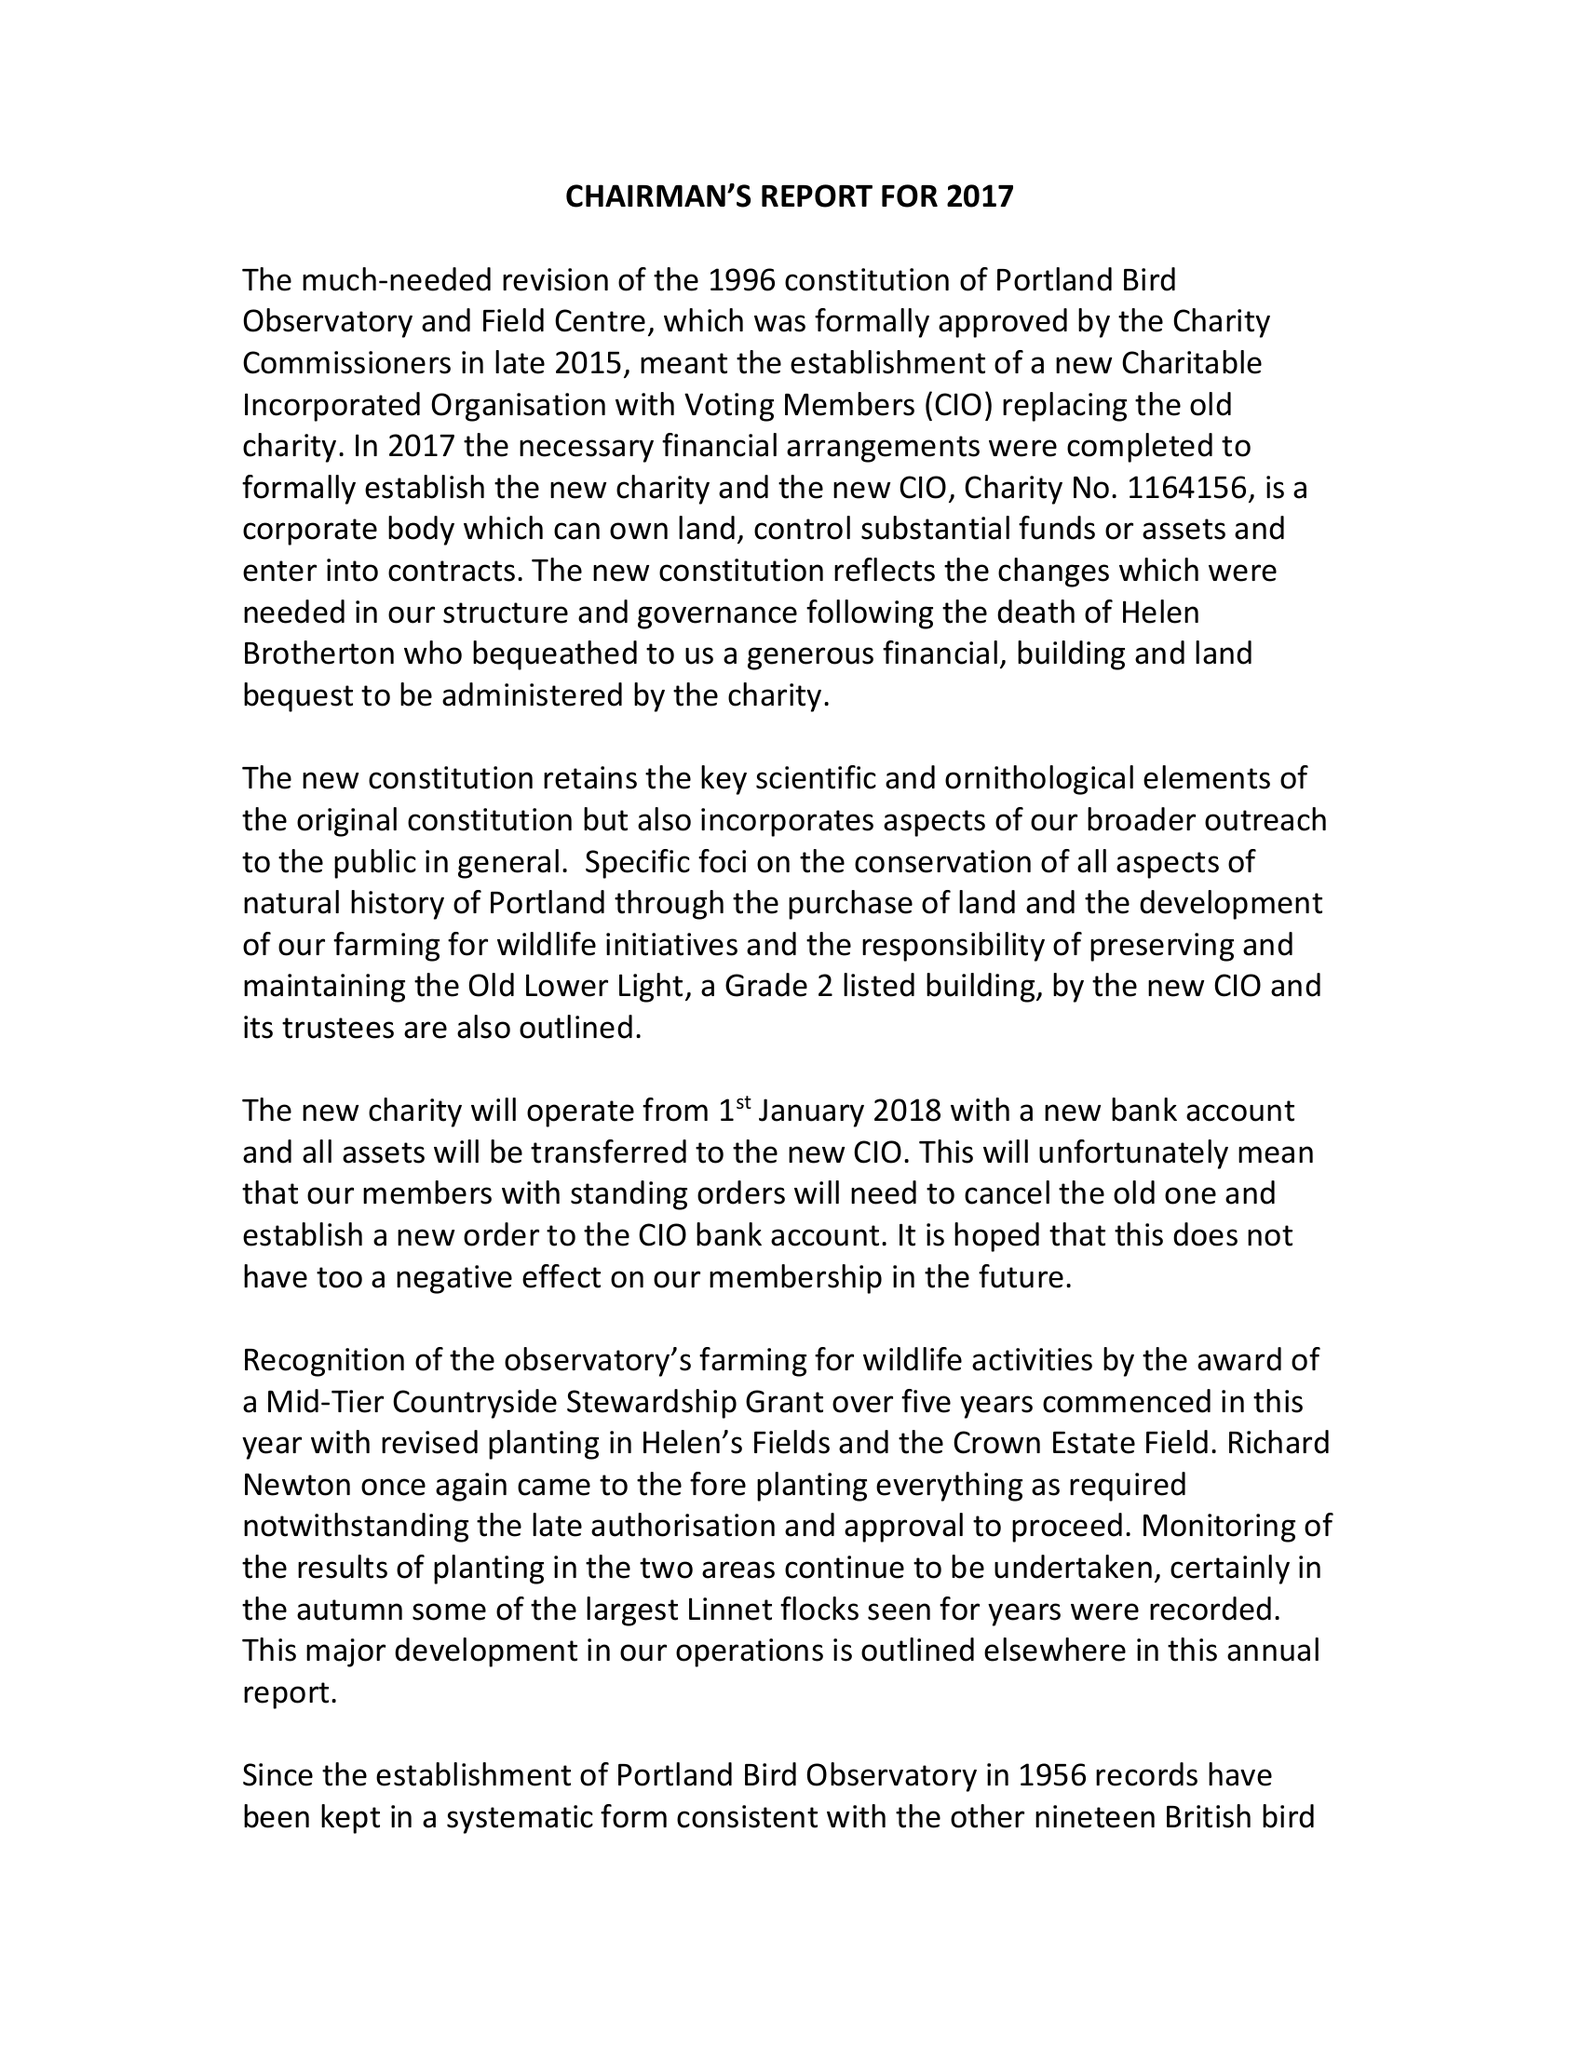What is the value for the spending_annually_in_british_pounds?
Answer the question using a single word or phrase. 81736.58 